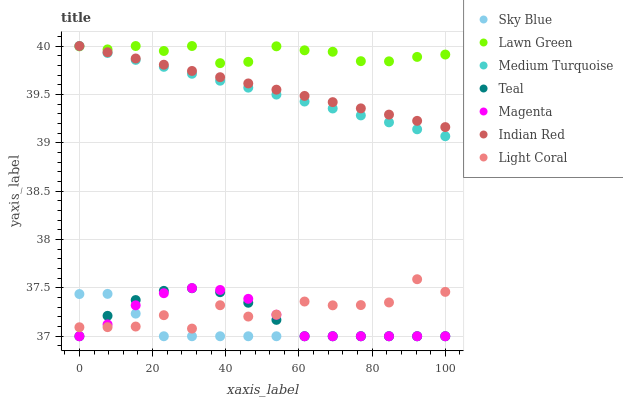Does Sky Blue have the minimum area under the curve?
Answer yes or no. Yes. Does Lawn Green have the maximum area under the curve?
Answer yes or no. Yes. Does Medium Turquoise have the minimum area under the curve?
Answer yes or no. No. Does Medium Turquoise have the maximum area under the curve?
Answer yes or no. No. Is Indian Red the smoothest?
Answer yes or no. Yes. Is Light Coral the roughest?
Answer yes or no. Yes. Is Medium Turquoise the smoothest?
Answer yes or no. No. Is Medium Turquoise the roughest?
Answer yes or no. No. Does Teal have the lowest value?
Answer yes or no. Yes. Does Medium Turquoise have the lowest value?
Answer yes or no. No. Does Indian Red have the highest value?
Answer yes or no. Yes. Does Teal have the highest value?
Answer yes or no. No. Is Teal less than Medium Turquoise?
Answer yes or no. Yes. Is Indian Red greater than Light Coral?
Answer yes or no. Yes. Does Sky Blue intersect Magenta?
Answer yes or no. Yes. Is Sky Blue less than Magenta?
Answer yes or no. No. Is Sky Blue greater than Magenta?
Answer yes or no. No. Does Teal intersect Medium Turquoise?
Answer yes or no. No. 